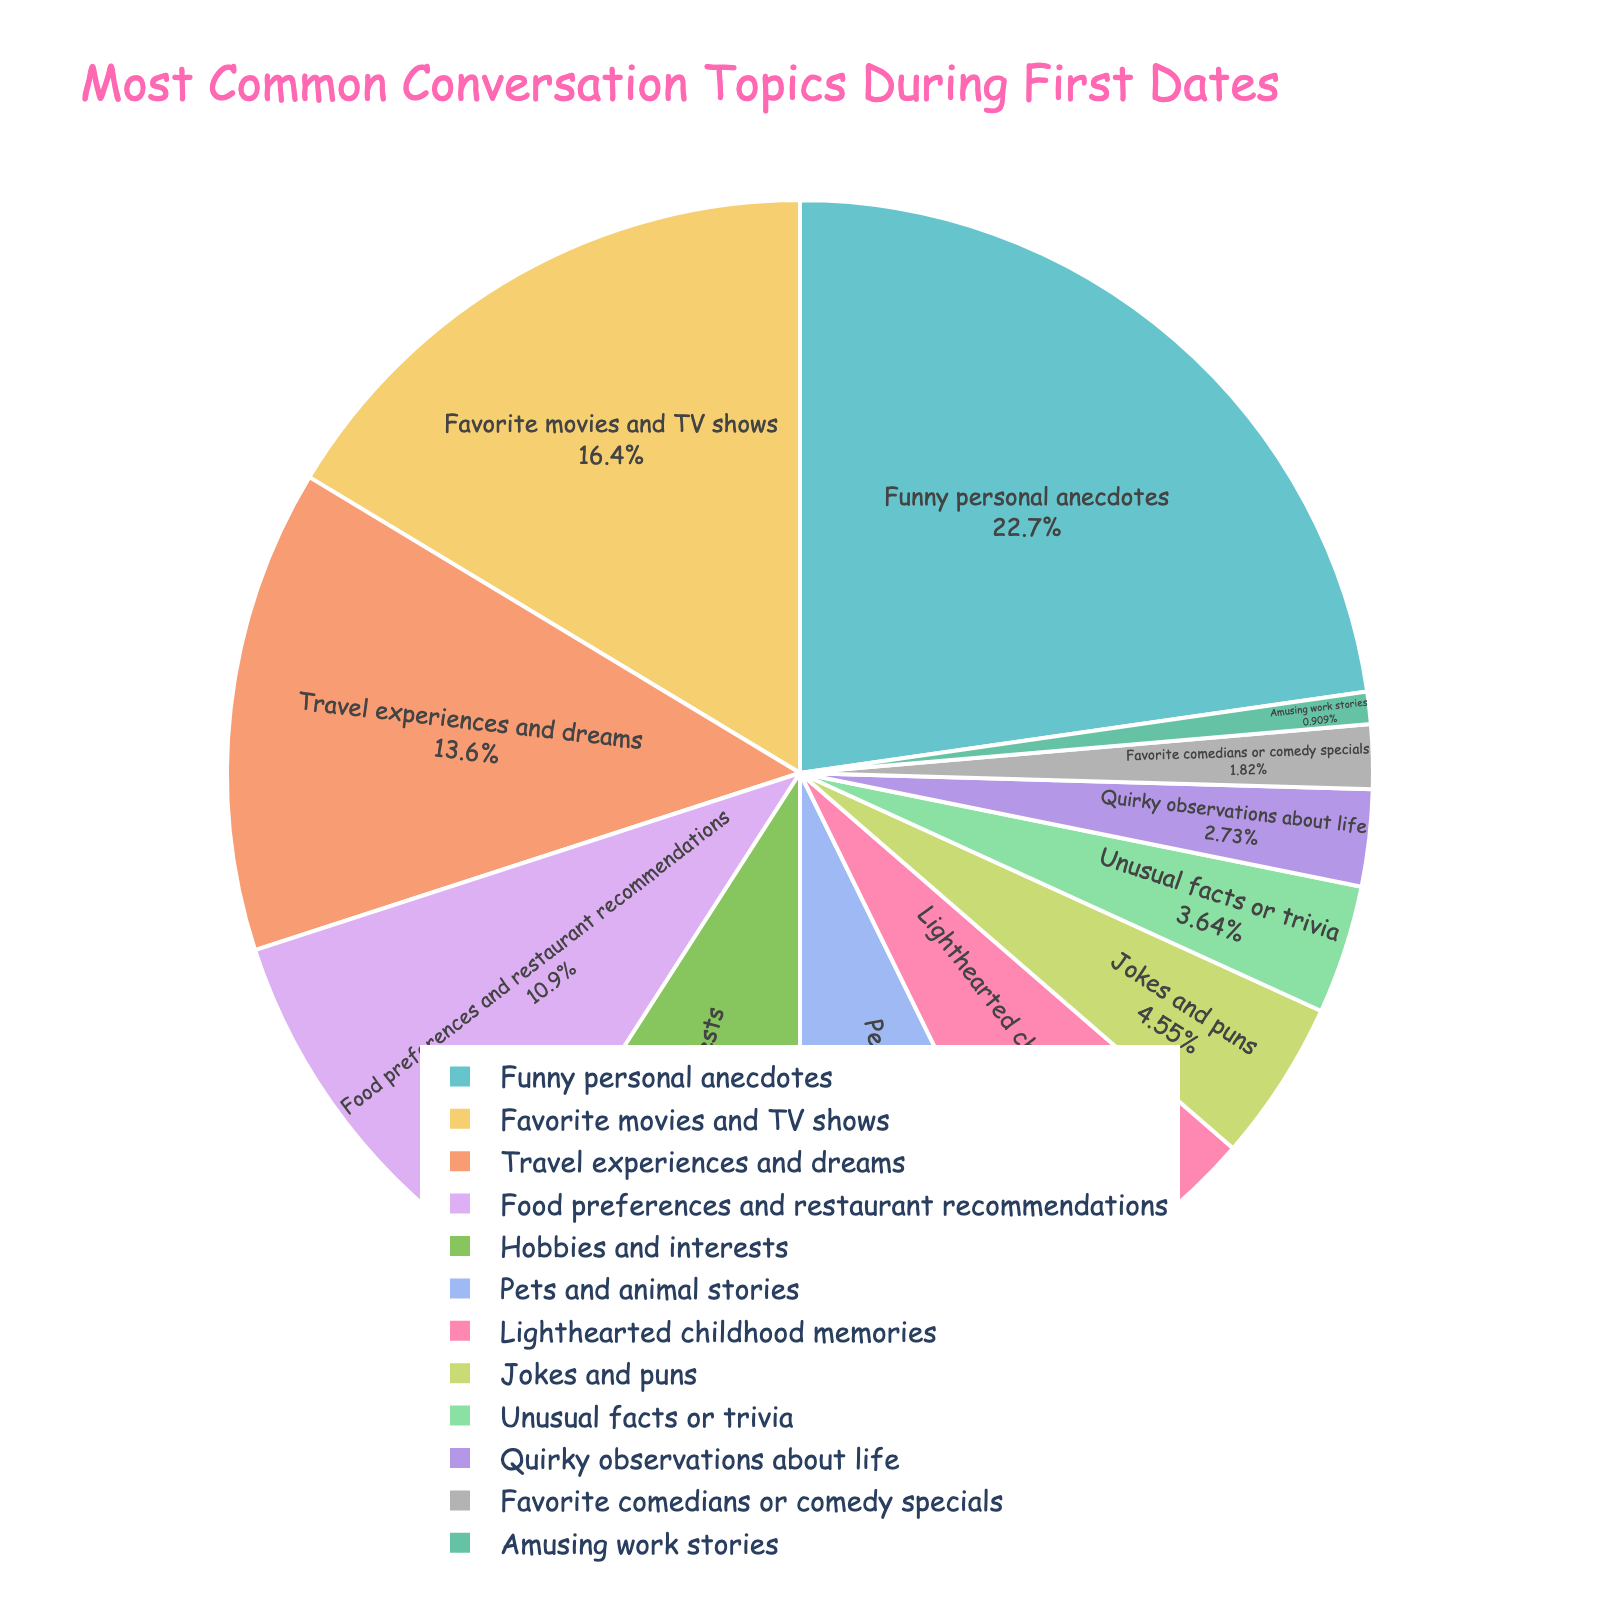What is the most common conversation topic during first dates? The largest segment of the pie chart represents "Funny personal anecdotes", which means it has the highest frequency among the listed topics.
Answer: Funny personal anecdotes What percentage of first date conversations involve pets and animal stories? Look for the segment labeled "Pets and animal stories" and read the percentage inside it.
Answer: 8% Which conversation topic is more frequent: travel experiences and dreams or hobbies and interests? Compare the pie chart segments for "Travel experiences and dreams" and "Hobbies and interests". The segment with the larger slice represents the more frequent topic.
Answer: Travel experiences and dreams How much more frequent are food preferences and restaurant recommendations compared to jokes and puns? Check the frequencies: Food preferences and restaurant recommendations have a frequency of 12, jokes and puns have 5. Subtract the two values.
Answer: 7 What is the combined frequency of favorite movies and TV shows and lighthearted childhood memories? Add the frequencies of these two topics: 18 (Favorite movies and TV shows) + 7 (Lighthearted childhood memories).
Answer: 25 Which topic has the smallest frequency and what is it? Identify the smallest segment in the pie chart.
Answer: Amusing work stories Are quirky observations about life more or less frequent than unusual facts or trivia? Compare the frequencies of these two topics: quirky observations about life (3) and unusual facts or trivia (4).
Answer: Less frequent What's the second most common conversation topic during first dates? Identify the second largest segment in the pie chart.
Answer: Favorite movies and TV shows If you combine the frequencies of the three least common topics, what is the total frequency? Add the frequencies of the three least common topics: 1 (Amusing work stories) + 2 (Favorite comedians or comedy specials) + 3 (Quirky observations about life).
Answer: 6 What fraction of the conversation topics involve sharing personal experiences (looking at topics like funny personal anecdotes, travel experiences and childhood memories)? Add the frequencies of funny personal anecdotes (25), travel experiences (15), and lighthearted childhood memories (7), and then find the fraction of the total frequency. The total frequency is 110, so the fraction is (25 + 15 + 7) / 110.
Answer: 47/110 